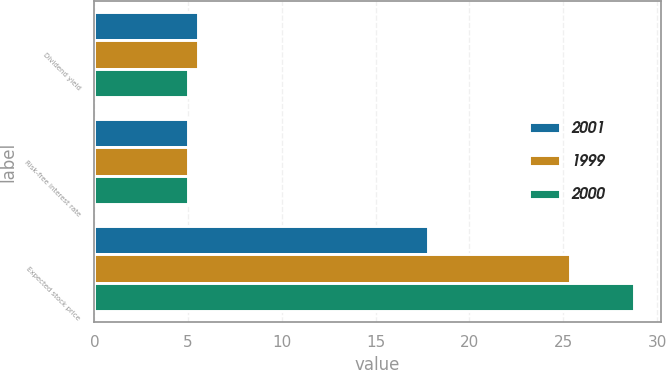Convert chart to OTSL. <chart><loc_0><loc_0><loc_500><loc_500><stacked_bar_chart><ecel><fcel>Dividend yield<fcel>Risk-free interest rate<fcel>Expected stock price<nl><fcel>2001<fcel>5.5<fcel>5<fcel>17.81<nl><fcel>1999<fcel>5.5<fcel>5<fcel>25.35<nl><fcel>2000<fcel>5<fcel>5<fcel>28.76<nl></chart> 